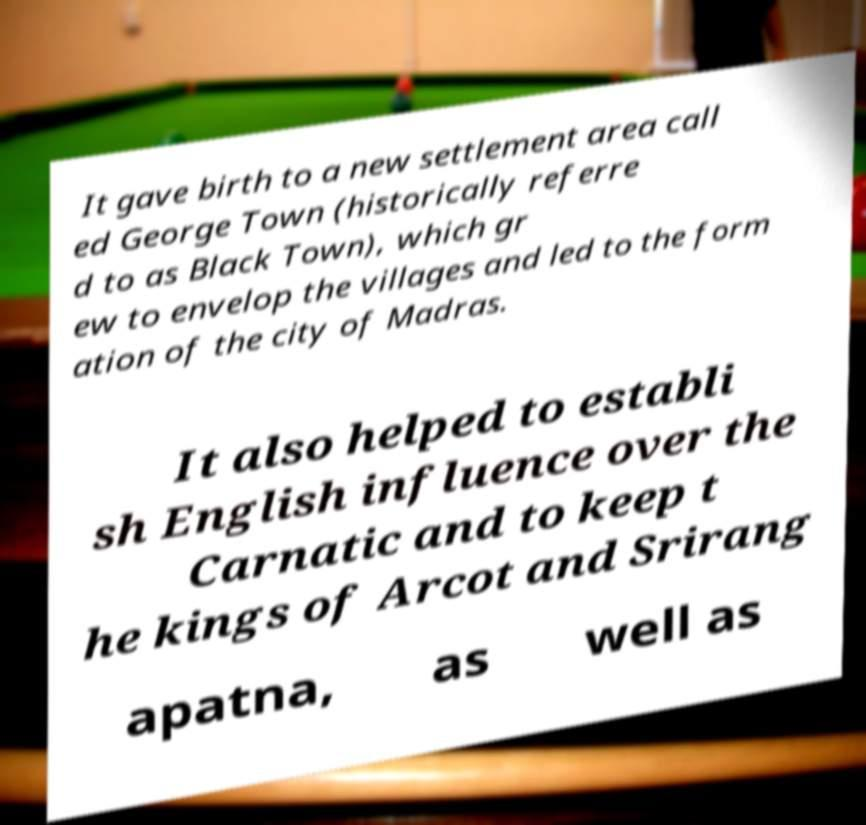Please read and relay the text visible in this image. What does it say? It gave birth to a new settlement area call ed George Town (historically referre d to as Black Town), which gr ew to envelop the villages and led to the form ation of the city of Madras. It also helped to establi sh English influence over the Carnatic and to keep t he kings of Arcot and Srirang apatna, as well as 